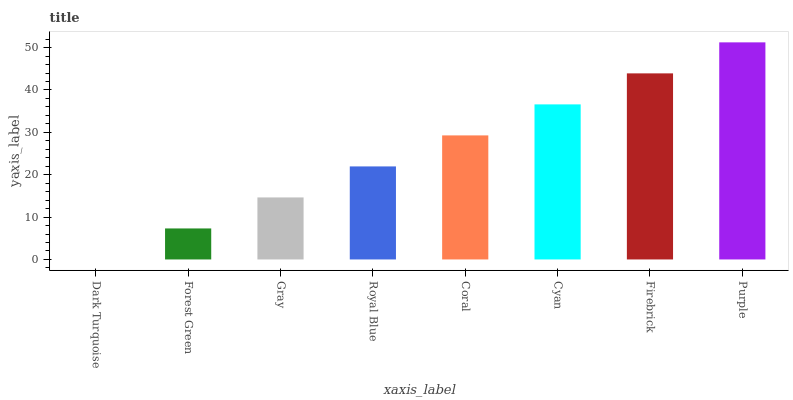Is Purple the maximum?
Answer yes or no. Yes. Is Forest Green the minimum?
Answer yes or no. No. Is Forest Green the maximum?
Answer yes or no. No. Is Forest Green greater than Dark Turquoise?
Answer yes or no. Yes. Is Dark Turquoise less than Forest Green?
Answer yes or no. Yes. Is Dark Turquoise greater than Forest Green?
Answer yes or no. No. Is Forest Green less than Dark Turquoise?
Answer yes or no. No. Is Coral the high median?
Answer yes or no. Yes. Is Royal Blue the low median?
Answer yes or no. Yes. Is Firebrick the high median?
Answer yes or no. No. Is Dark Turquoise the low median?
Answer yes or no. No. 